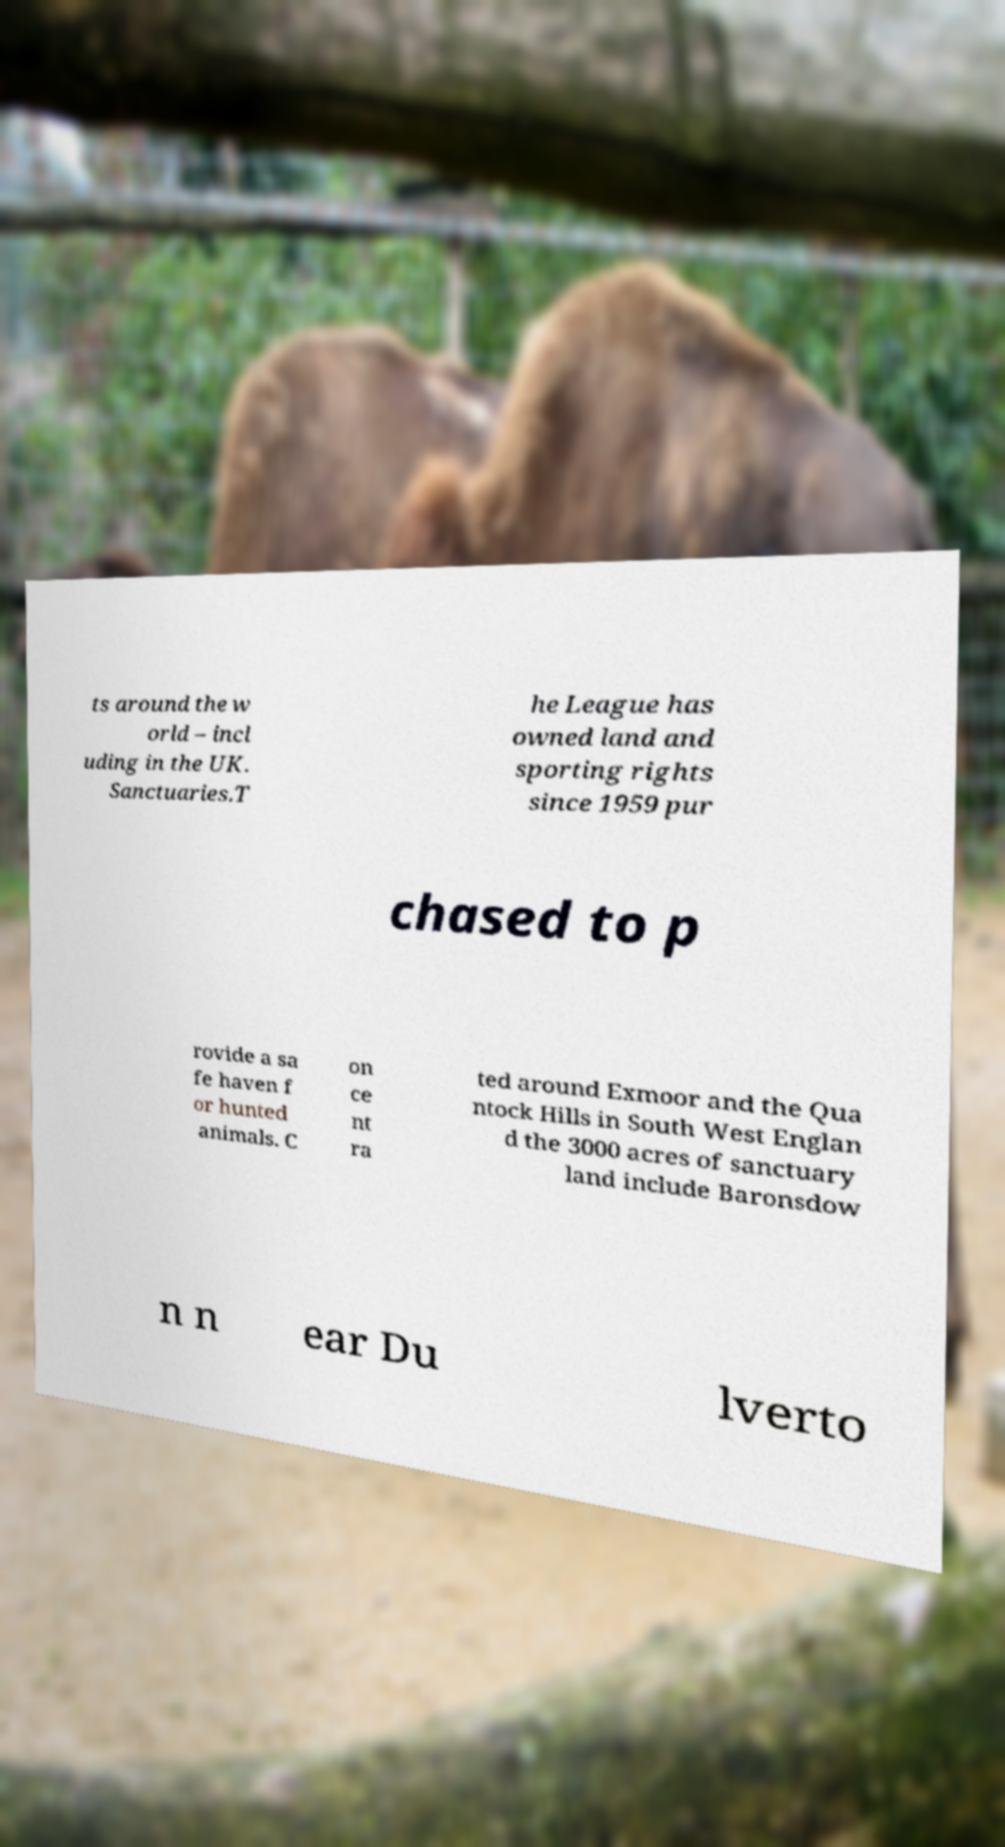Please identify and transcribe the text found in this image. ts around the w orld – incl uding in the UK. Sanctuaries.T he League has owned land and sporting rights since 1959 pur chased to p rovide a sa fe haven f or hunted animals. C on ce nt ra ted around Exmoor and the Qua ntock Hills in South West Englan d the 3000 acres of sanctuary land include Baronsdow n n ear Du lverto 